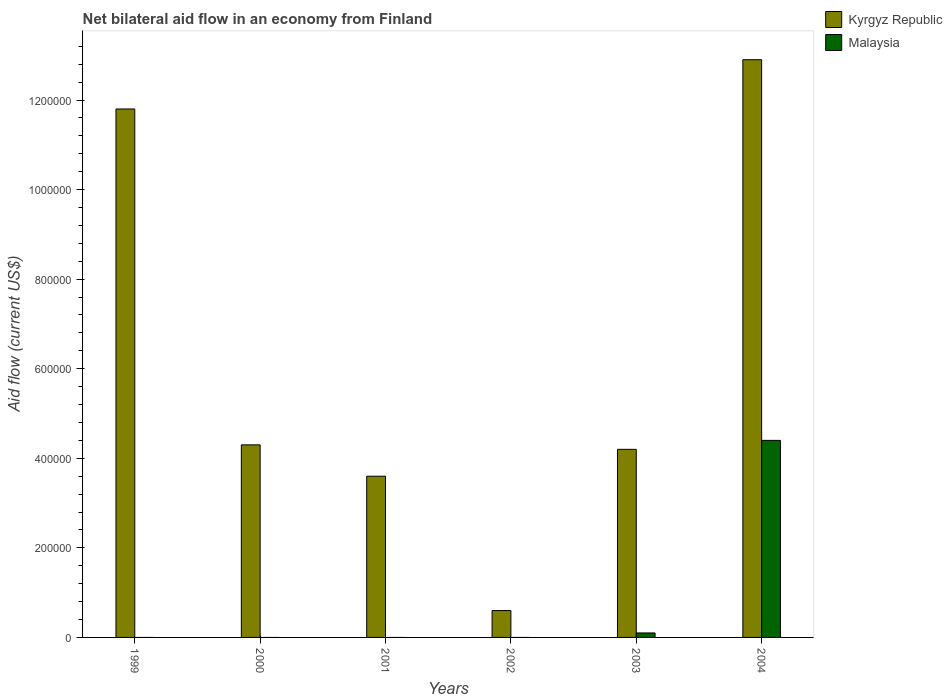How many different coloured bars are there?
Give a very brief answer. 2. Are the number of bars on each tick of the X-axis equal?
Offer a terse response. No. What is the net bilateral aid flow in Kyrgyz Republic in 2002?
Your answer should be compact. 6.00e+04. Across all years, what is the maximum net bilateral aid flow in Kyrgyz Republic?
Keep it short and to the point. 1.29e+06. What is the total net bilateral aid flow in Kyrgyz Republic in the graph?
Give a very brief answer. 3.74e+06. What is the difference between the net bilateral aid flow in Kyrgyz Republic in 2001 and that in 2003?
Provide a short and direct response. -6.00e+04. What is the difference between the net bilateral aid flow in Kyrgyz Republic in 2003 and the net bilateral aid flow in Malaysia in 2002?
Ensure brevity in your answer.  4.20e+05. What is the average net bilateral aid flow in Malaysia per year?
Provide a short and direct response. 7.50e+04. In the year 2003, what is the difference between the net bilateral aid flow in Kyrgyz Republic and net bilateral aid flow in Malaysia?
Provide a succinct answer. 4.10e+05. In how many years, is the net bilateral aid flow in Malaysia greater than 1200000 US$?
Keep it short and to the point. 0. What is the ratio of the net bilateral aid flow in Kyrgyz Republic in 2000 to that in 2002?
Give a very brief answer. 7.17. Is the net bilateral aid flow in Kyrgyz Republic in 2000 less than that in 2002?
Give a very brief answer. No. What is the difference between the highest and the lowest net bilateral aid flow in Malaysia?
Your answer should be very brief. 4.40e+05. In how many years, is the net bilateral aid flow in Malaysia greater than the average net bilateral aid flow in Malaysia taken over all years?
Your response must be concise. 1. Does the graph contain any zero values?
Offer a terse response. Yes. How many legend labels are there?
Make the answer very short. 2. How are the legend labels stacked?
Offer a terse response. Vertical. What is the title of the graph?
Provide a succinct answer. Net bilateral aid flow in an economy from Finland. What is the label or title of the X-axis?
Make the answer very short. Years. What is the label or title of the Y-axis?
Offer a terse response. Aid flow (current US$). What is the Aid flow (current US$) of Kyrgyz Republic in 1999?
Make the answer very short. 1.18e+06. What is the Aid flow (current US$) of Kyrgyz Republic in 2000?
Your response must be concise. 4.30e+05. What is the Aid flow (current US$) in Malaysia in 2000?
Your response must be concise. 0. What is the Aid flow (current US$) of Malaysia in 2001?
Make the answer very short. 0. What is the Aid flow (current US$) of Malaysia in 2003?
Ensure brevity in your answer.  10000. What is the Aid flow (current US$) in Kyrgyz Republic in 2004?
Make the answer very short. 1.29e+06. What is the Aid flow (current US$) in Malaysia in 2004?
Offer a terse response. 4.40e+05. Across all years, what is the maximum Aid flow (current US$) of Kyrgyz Republic?
Provide a short and direct response. 1.29e+06. Across all years, what is the minimum Aid flow (current US$) in Kyrgyz Republic?
Provide a short and direct response. 6.00e+04. Across all years, what is the minimum Aid flow (current US$) of Malaysia?
Provide a succinct answer. 0. What is the total Aid flow (current US$) in Kyrgyz Republic in the graph?
Keep it short and to the point. 3.74e+06. What is the total Aid flow (current US$) of Malaysia in the graph?
Your response must be concise. 4.50e+05. What is the difference between the Aid flow (current US$) in Kyrgyz Republic in 1999 and that in 2000?
Make the answer very short. 7.50e+05. What is the difference between the Aid flow (current US$) of Kyrgyz Republic in 1999 and that in 2001?
Make the answer very short. 8.20e+05. What is the difference between the Aid flow (current US$) of Kyrgyz Republic in 1999 and that in 2002?
Offer a terse response. 1.12e+06. What is the difference between the Aid flow (current US$) of Kyrgyz Republic in 1999 and that in 2003?
Provide a short and direct response. 7.60e+05. What is the difference between the Aid flow (current US$) of Kyrgyz Republic in 1999 and that in 2004?
Offer a very short reply. -1.10e+05. What is the difference between the Aid flow (current US$) in Kyrgyz Republic in 2000 and that in 2002?
Offer a very short reply. 3.70e+05. What is the difference between the Aid flow (current US$) in Kyrgyz Republic in 2000 and that in 2003?
Your answer should be compact. 10000. What is the difference between the Aid flow (current US$) of Kyrgyz Republic in 2000 and that in 2004?
Give a very brief answer. -8.60e+05. What is the difference between the Aid flow (current US$) of Kyrgyz Republic in 2001 and that in 2003?
Make the answer very short. -6.00e+04. What is the difference between the Aid flow (current US$) of Kyrgyz Republic in 2001 and that in 2004?
Provide a succinct answer. -9.30e+05. What is the difference between the Aid flow (current US$) of Kyrgyz Republic in 2002 and that in 2003?
Ensure brevity in your answer.  -3.60e+05. What is the difference between the Aid flow (current US$) in Kyrgyz Republic in 2002 and that in 2004?
Give a very brief answer. -1.23e+06. What is the difference between the Aid flow (current US$) in Kyrgyz Republic in 2003 and that in 2004?
Your answer should be very brief. -8.70e+05. What is the difference between the Aid flow (current US$) in Malaysia in 2003 and that in 2004?
Offer a terse response. -4.30e+05. What is the difference between the Aid flow (current US$) in Kyrgyz Republic in 1999 and the Aid flow (current US$) in Malaysia in 2003?
Give a very brief answer. 1.17e+06. What is the difference between the Aid flow (current US$) of Kyrgyz Republic in 1999 and the Aid flow (current US$) of Malaysia in 2004?
Ensure brevity in your answer.  7.40e+05. What is the difference between the Aid flow (current US$) in Kyrgyz Republic in 2000 and the Aid flow (current US$) in Malaysia in 2003?
Keep it short and to the point. 4.20e+05. What is the difference between the Aid flow (current US$) of Kyrgyz Republic in 2000 and the Aid flow (current US$) of Malaysia in 2004?
Make the answer very short. -10000. What is the difference between the Aid flow (current US$) of Kyrgyz Republic in 2001 and the Aid flow (current US$) of Malaysia in 2004?
Your answer should be compact. -8.00e+04. What is the difference between the Aid flow (current US$) of Kyrgyz Republic in 2002 and the Aid flow (current US$) of Malaysia in 2003?
Your answer should be very brief. 5.00e+04. What is the difference between the Aid flow (current US$) of Kyrgyz Republic in 2002 and the Aid flow (current US$) of Malaysia in 2004?
Your answer should be very brief. -3.80e+05. What is the average Aid flow (current US$) in Kyrgyz Republic per year?
Provide a short and direct response. 6.23e+05. What is the average Aid flow (current US$) of Malaysia per year?
Your answer should be compact. 7.50e+04. In the year 2003, what is the difference between the Aid flow (current US$) of Kyrgyz Republic and Aid flow (current US$) of Malaysia?
Your answer should be compact. 4.10e+05. In the year 2004, what is the difference between the Aid flow (current US$) in Kyrgyz Republic and Aid flow (current US$) in Malaysia?
Your answer should be very brief. 8.50e+05. What is the ratio of the Aid flow (current US$) of Kyrgyz Republic in 1999 to that in 2000?
Ensure brevity in your answer.  2.74. What is the ratio of the Aid flow (current US$) of Kyrgyz Republic in 1999 to that in 2001?
Offer a terse response. 3.28. What is the ratio of the Aid flow (current US$) of Kyrgyz Republic in 1999 to that in 2002?
Give a very brief answer. 19.67. What is the ratio of the Aid flow (current US$) of Kyrgyz Republic in 1999 to that in 2003?
Your answer should be very brief. 2.81. What is the ratio of the Aid flow (current US$) of Kyrgyz Republic in 1999 to that in 2004?
Keep it short and to the point. 0.91. What is the ratio of the Aid flow (current US$) of Kyrgyz Republic in 2000 to that in 2001?
Offer a very short reply. 1.19. What is the ratio of the Aid flow (current US$) of Kyrgyz Republic in 2000 to that in 2002?
Ensure brevity in your answer.  7.17. What is the ratio of the Aid flow (current US$) of Kyrgyz Republic in 2000 to that in 2003?
Give a very brief answer. 1.02. What is the ratio of the Aid flow (current US$) in Kyrgyz Republic in 2001 to that in 2002?
Ensure brevity in your answer.  6. What is the ratio of the Aid flow (current US$) in Kyrgyz Republic in 2001 to that in 2003?
Your answer should be very brief. 0.86. What is the ratio of the Aid flow (current US$) of Kyrgyz Republic in 2001 to that in 2004?
Your response must be concise. 0.28. What is the ratio of the Aid flow (current US$) of Kyrgyz Republic in 2002 to that in 2003?
Your response must be concise. 0.14. What is the ratio of the Aid flow (current US$) in Kyrgyz Republic in 2002 to that in 2004?
Provide a succinct answer. 0.05. What is the ratio of the Aid flow (current US$) of Kyrgyz Republic in 2003 to that in 2004?
Provide a short and direct response. 0.33. What is the ratio of the Aid flow (current US$) of Malaysia in 2003 to that in 2004?
Your answer should be very brief. 0.02. What is the difference between the highest and the second highest Aid flow (current US$) of Kyrgyz Republic?
Your answer should be very brief. 1.10e+05. What is the difference between the highest and the lowest Aid flow (current US$) of Kyrgyz Republic?
Your answer should be very brief. 1.23e+06. 